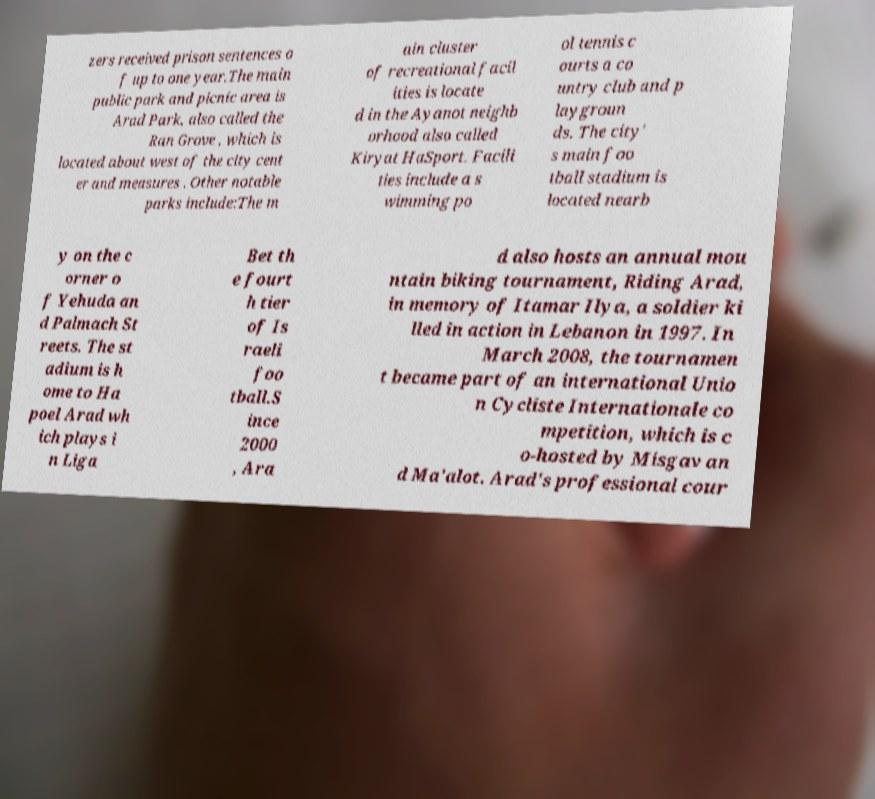Could you assist in decoding the text presented in this image and type it out clearly? zers received prison sentences o f up to one year.The main public park and picnic area is Arad Park, also called the Ran Grove , which is located about west of the city cent er and measures . Other notable parks include:The m ain cluster of recreational facil ities is locate d in the Ayanot neighb orhood also called Kiryat HaSport. Facili ties include a s wimming po ol tennis c ourts a co untry club and p laygroun ds. The city' s main foo tball stadium is located nearb y on the c orner o f Yehuda an d Palmach St reets. The st adium is h ome to Ha poel Arad wh ich plays i n Liga Bet th e fourt h tier of Is raeli foo tball.S ince 2000 , Ara d also hosts an annual mou ntain biking tournament, Riding Arad, in memory of Itamar Ilya, a soldier ki lled in action in Lebanon in 1997. In March 2008, the tournamen t became part of an international Unio n Cycliste Internationale co mpetition, which is c o-hosted by Misgav an d Ma'alot. Arad's professional cour 